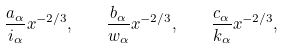Convert formula to latex. <formula><loc_0><loc_0><loc_500><loc_500>\frac { a _ { \alpha } } { i _ { \alpha } } x ^ { - 2 / 3 } , \quad \frac { b _ { \alpha } } { w _ { \alpha } } x ^ { - 2 / 3 } , \quad \frac { c _ { \alpha } } { k _ { \alpha } } x ^ { - 2 / 3 } ,</formula> 